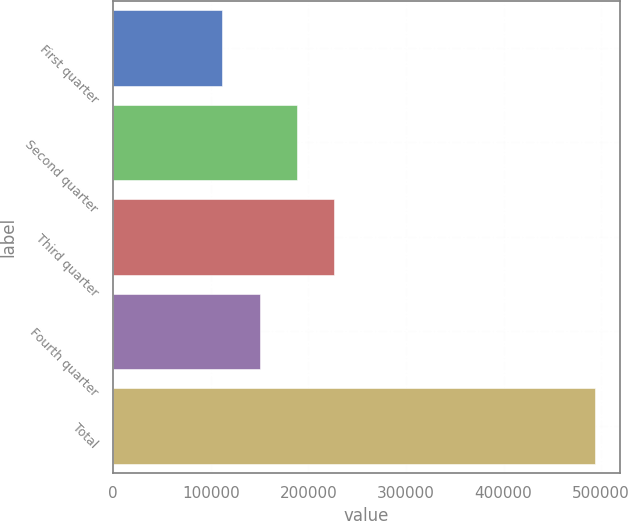Convert chart to OTSL. <chart><loc_0><loc_0><loc_500><loc_500><bar_chart><fcel>First quarter<fcel>Second quarter<fcel>Third quarter<fcel>Fourth quarter<fcel>Total<nl><fcel>111931<fcel>188375<fcel>226597<fcel>150153<fcel>494150<nl></chart> 